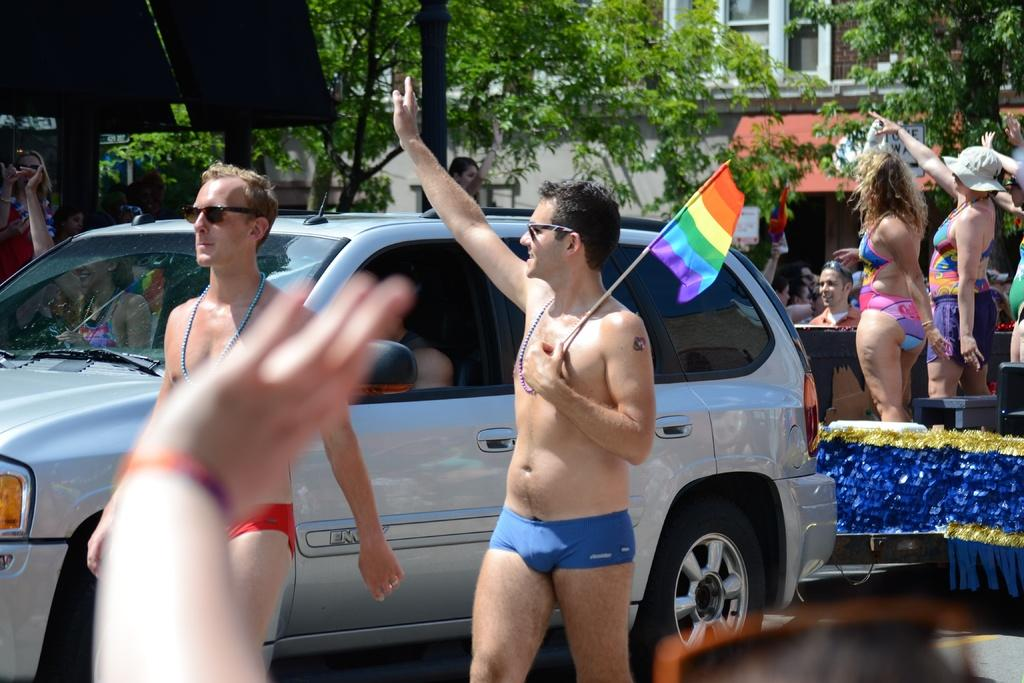Who or what can be seen in the image? There are people in the image. What type of natural elements are present in the image? There are trees in the image. Are there any man-made structures visible in the image? Yes, there is a building in the image. What type of vehicle can be seen in the image? There is a white color car in the image. What is the man in the image doing? A man is holding a flag in the image. Can you see any ghosts or whips in the image? No, there are no ghosts or whips present in the image. 